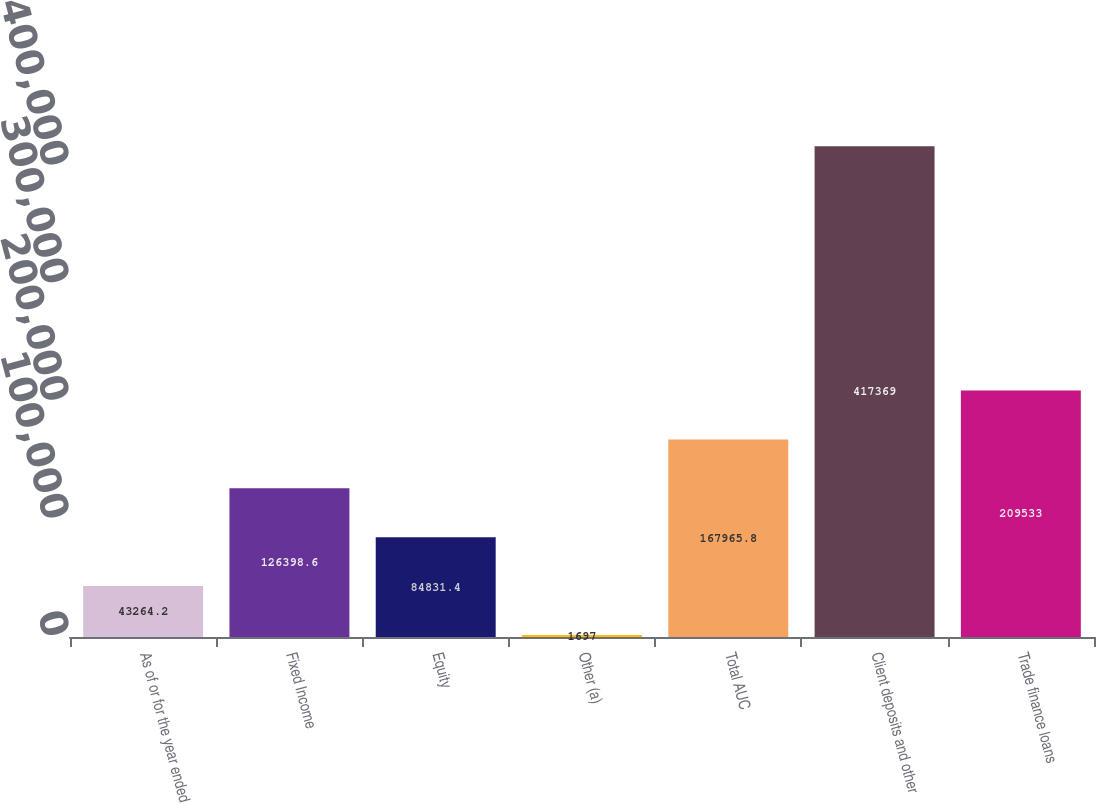Convert chart to OTSL. <chart><loc_0><loc_0><loc_500><loc_500><bar_chart><fcel>As of or for the year ended<fcel>Fixed Income<fcel>Equity<fcel>Other (a)<fcel>Total AUC<fcel>Client deposits and other<fcel>Trade finance loans<nl><fcel>43264.2<fcel>126399<fcel>84831.4<fcel>1697<fcel>167966<fcel>417369<fcel>209533<nl></chart> 